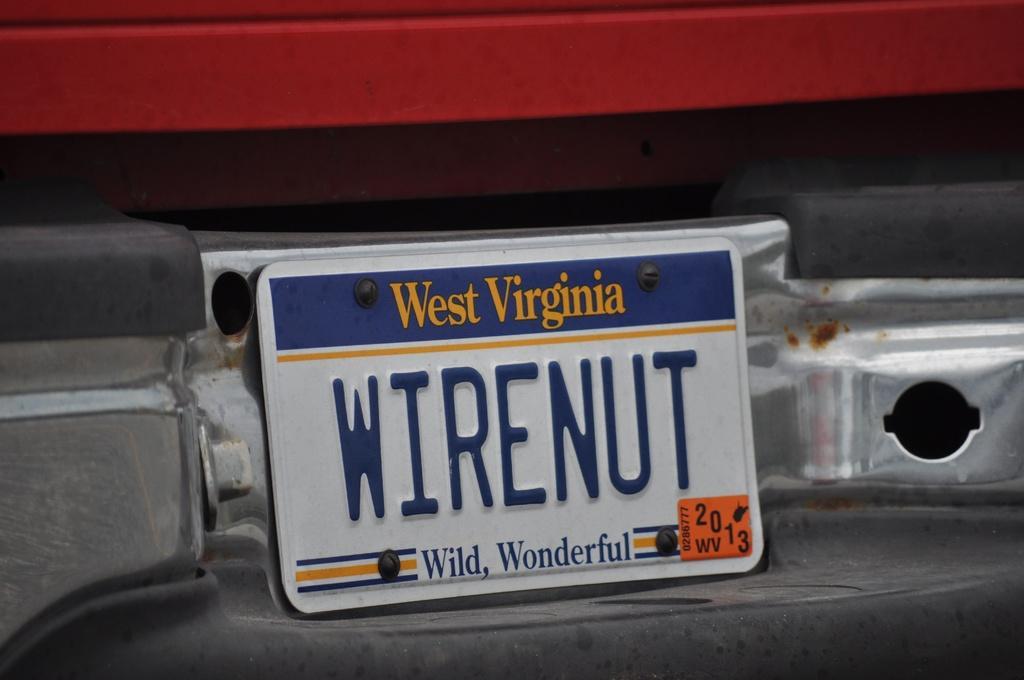How would you summarize this image in a sentence or two? In the picture we can see a backside part of the car with a board on it we can see a name west Virginia and wire nut, wild wonderful. 